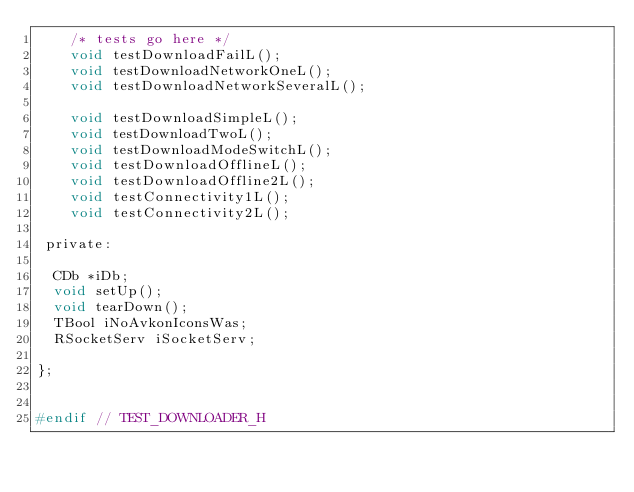<code> <loc_0><loc_0><loc_500><loc_500><_C_>	/* tests go here */
    void testDownloadFailL();
    void testDownloadNetworkOneL();
    void testDownloadNetworkSeveralL();
    
    void testDownloadSimpleL();
    void testDownloadTwoL();
    void testDownloadModeSwitchL();
    void testDownloadOfflineL();
    void testDownloadOffline2L();
    void testConnectivity1L();
    void testConnectivity2L();

 private:
 	
  CDb *iDb;
  void setUp();
  void tearDown();
  TBool iNoAvkonIconsWas;
  RSocketServ iSocketServ;

};


#endif // TEST_DOWNLOADER_H
</code> 